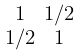Convert formula to latex. <formula><loc_0><loc_0><loc_500><loc_500>\begin{smallmatrix} 1 & 1 / 2 \\ 1 / 2 & 1 \end{smallmatrix}</formula> 